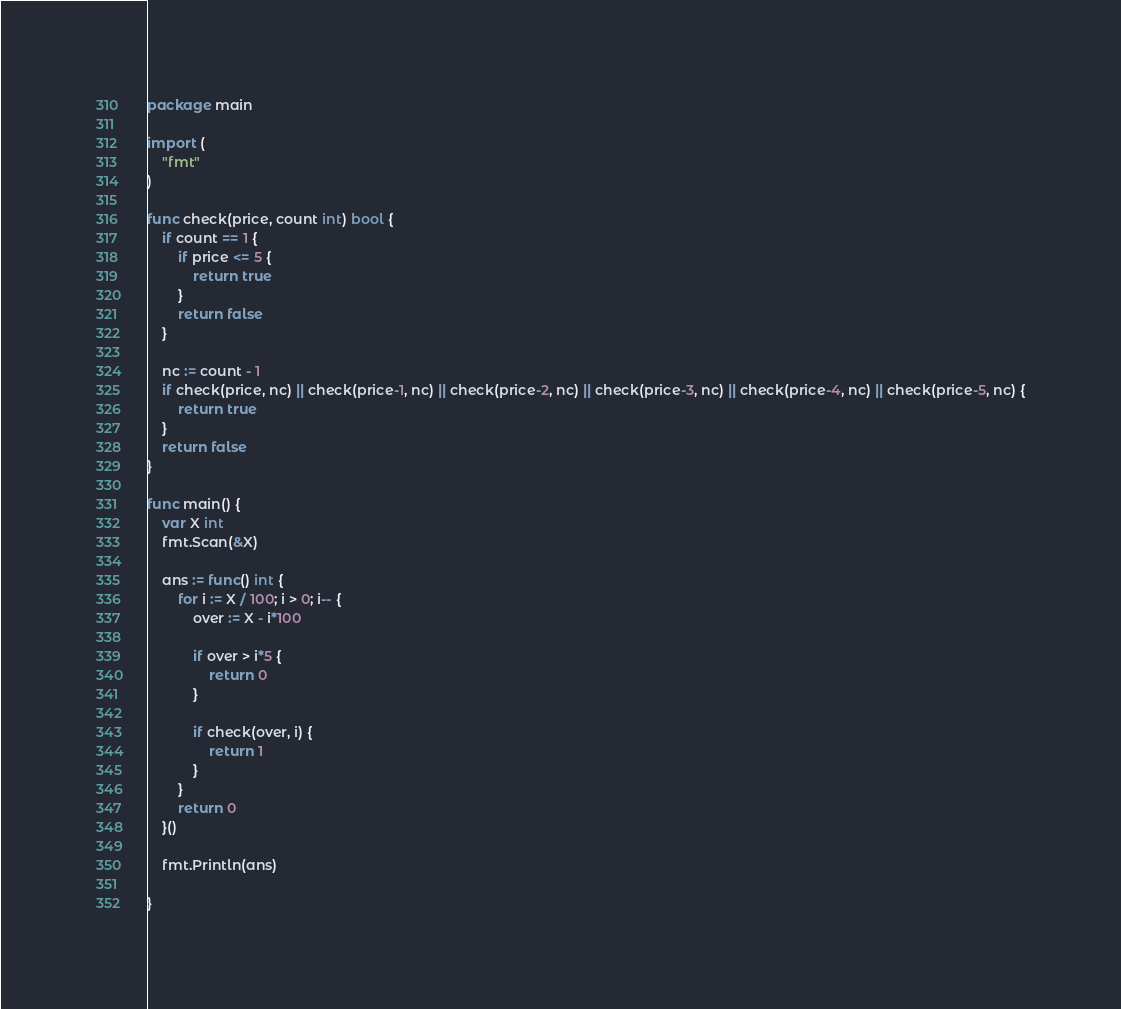<code> <loc_0><loc_0><loc_500><loc_500><_Go_>package main

import (
	"fmt"
)

func check(price, count int) bool {
	if count == 1 {
		if price <= 5 {
			return true
		}
		return false
	}

	nc := count - 1
	if check(price, nc) || check(price-1, nc) || check(price-2, nc) || check(price-3, nc) || check(price-4, nc) || check(price-5, nc) {
		return true
	}
	return false
}

func main() {
	var X int
	fmt.Scan(&X)

	ans := func() int {
		for i := X / 100; i > 0; i-- {
			over := X - i*100

			if over > i*5 {
				return 0
			}

			if check(over, i) {
				return 1
			}
		}
		return 0
	}()

	fmt.Println(ans)

}
</code> 